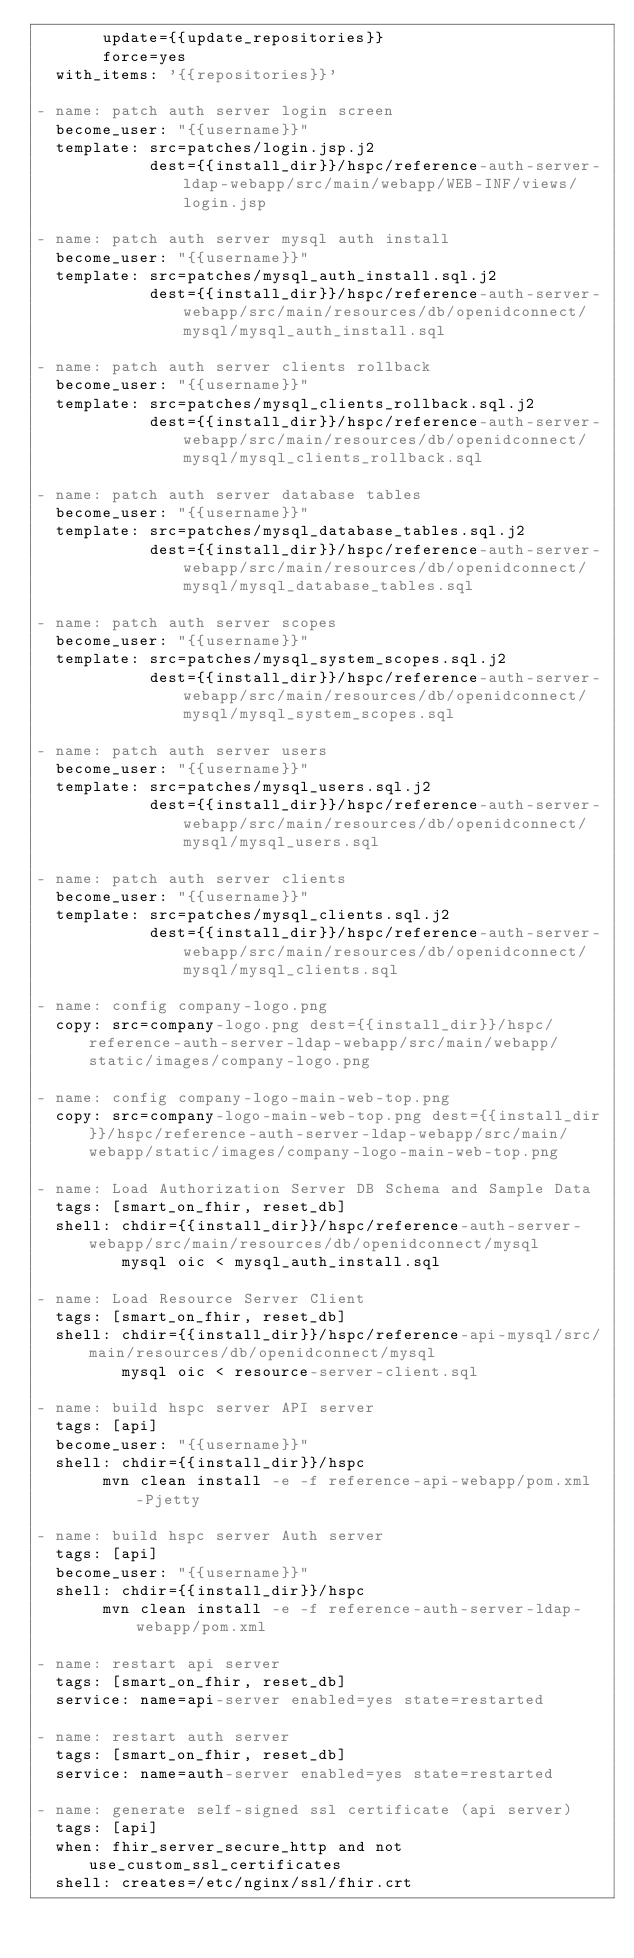Convert code to text. <code><loc_0><loc_0><loc_500><loc_500><_YAML_>       update={{update_repositories}}
       force=yes
  with_items: '{{repositories}}'

- name: patch auth server login screen
  become_user: "{{username}}"
  template: src=patches/login.jsp.j2
            dest={{install_dir}}/hspc/reference-auth-server-ldap-webapp/src/main/webapp/WEB-INF/views/login.jsp

- name: patch auth server mysql auth install
  become_user: "{{username}}"
  template: src=patches/mysql_auth_install.sql.j2
            dest={{install_dir}}/hspc/reference-auth-server-webapp/src/main/resources/db/openidconnect/mysql/mysql_auth_install.sql

- name: patch auth server clients rollback
  become_user: "{{username}}"
  template: src=patches/mysql_clients_rollback.sql.j2
            dest={{install_dir}}/hspc/reference-auth-server-webapp/src/main/resources/db/openidconnect/mysql/mysql_clients_rollback.sql

- name: patch auth server database tables
  become_user: "{{username}}"
  template: src=patches/mysql_database_tables.sql.j2
            dest={{install_dir}}/hspc/reference-auth-server-webapp/src/main/resources/db/openidconnect/mysql/mysql_database_tables.sql

- name: patch auth server scopes
  become_user: "{{username}}"
  template: src=patches/mysql_system_scopes.sql.j2
            dest={{install_dir}}/hspc/reference-auth-server-webapp/src/main/resources/db/openidconnect/mysql/mysql_system_scopes.sql

- name: patch auth server users
  become_user: "{{username}}"
  template: src=patches/mysql_users.sql.j2
            dest={{install_dir}}/hspc/reference-auth-server-webapp/src/main/resources/db/openidconnect/mysql/mysql_users.sql

- name: patch auth server clients
  become_user: "{{username}}"
  template: src=patches/mysql_clients.sql.j2
            dest={{install_dir}}/hspc/reference-auth-server-webapp/src/main/resources/db/openidconnect/mysql/mysql_clients.sql

- name: config company-logo.png
  copy: src=company-logo.png dest={{install_dir}}/hspc/reference-auth-server-ldap-webapp/src/main/webapp/static/images/company-logo.png

- name: config company-logo-main-web-top.png
  copy: src=company-logo-main-web-top.png dest={{install_dir}}/hspc/reference-auth-server-ldap-webapp/src/main/webapp/static/images/company-logo-main-web-top.png

- name: Load Authorization Server DB Schema and Sample Data
  tags: [smart_on_fhir, reset_db]
  shell: chdir={{install_dir}}/hspc/reference-auth-server-webapp/src/main/resources/db/openidconnect/mysql
         mysql oic < mysql_auth_install.sql

- name: Load Resource Server Client
  tags: [smart_on_fhir, reset_db]
  shell: chdir={{install_dir}}/hspc/reference-api-mysql/src/main/resources/db/openidconnect/mysql
         mysql oic < resource-server-client.sql

- name: build hspc server API server
  tags: [api]
  become_user: "{{username}}"
  shell: chdir={{install_dir}}/hspc
       mvn clean install -e -f reference-api-webapp/pom.xml -Pjetty

- name: build hspc server Auth server
  tags: [api]
  become_user: "{{username}}"
  shell: chdir={{install_dir}}/hspc
       mvn clean install -e -f reference-auth-server-ldap-webapp/pom.xml

- name: restart api server
  tags: [smart_on_fhir, reset_db]
  service: name=api-server enabled=yes state=restarted

- name: restart auth server
  tags: [smart_on_fhir, reset_db]
  service: name=auth-server enabled=yes state=restarted

- name: generate self-signed ssl certificate (api server)
  tags: [api]
  when: fhir_server_secure_http and not use_custom_ssl_certificates
  shell: creates=/etc/nginx/ssl/fhir.crt</code> 